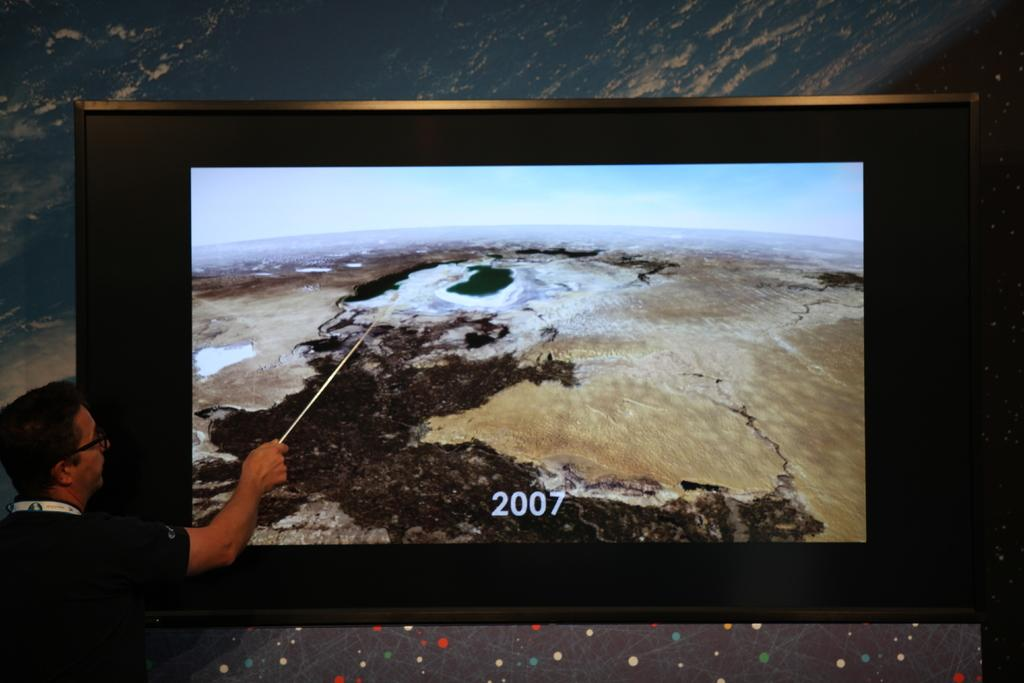<image>
Create a compact narrative representing the image presented. Man pointing at a screen which say 2007 on it. 